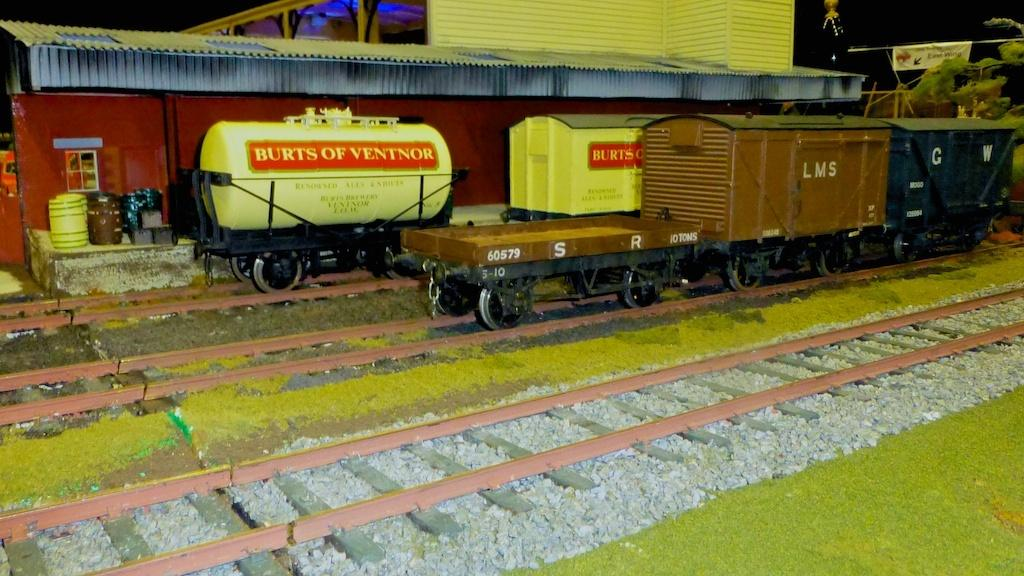What type of vehicles can be seen in the image? There are two trains on tracks in the image. What structure is present in the image? There is a building in the image. What additional item can be seen in the image? There is a banner in the image. What other object is visible in the image? There is a barrel in the image. What type of natural material is present in the image? There are stones in the image. Can you describe any other objects in the image? There are a few other objects in the image, but their specific details are not mentioned in the provided facts. What is the sun's role in the image? The provided facts do not mention the sun being present in the image. What is the birth rate of the people in the image? The provided facts do not mention any people or their birth rates in the image. 